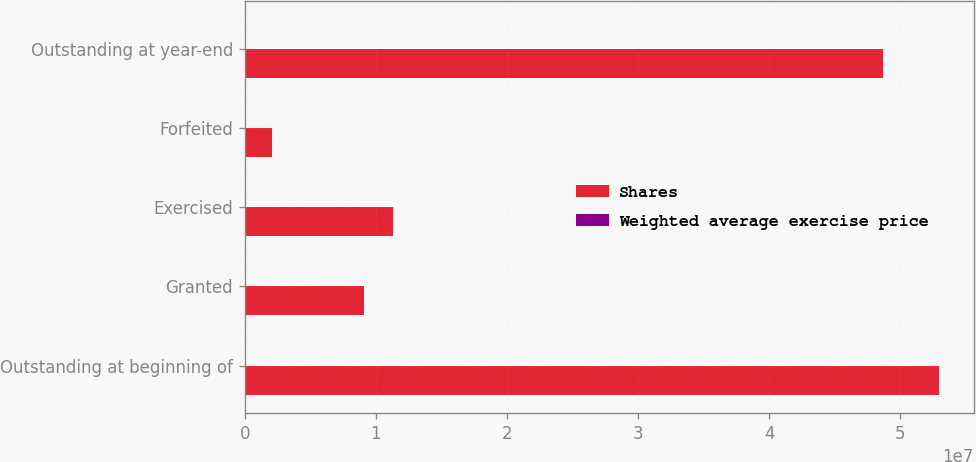Convert chart to OTSL. <chart><loc_0><loc_0><loc_500><loc_500><stacked_bar_chart><ecel><fcel>Outstanding at beginning of<fcel>Granted<fcel>Exercised<fcel>Forfeited<fcel>Outstanding at year-end<nl><fcel>Shares<fcel>5.29788e+07<fcel>9.05514e+06<fcel>1.1277e+07<fcel>2.07834e+06<fcel>4.86786e+07<nl><fcel>Weighted average exercise price<fcel>31.39<fcel>55.86<fcel>29.89<fcel>29.53<fcel>36.36<nl></chart> 